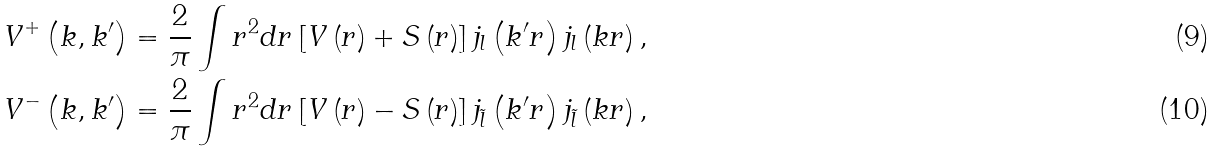Convert formula to latex. <formula><loc_0><loc_0><loc_500><loc_500>V ^ { + } \left ( k , k ^ { \prime } \right ) & = \frac { 2 } { \pi } \int r ^ { 2 } d r \left [ V \left ( r \right ) + S \left ( r \right ) \right ] j _ { l } \left ( k ^ { \prime } r \right ) j _ { l } \left ( k r \right ) , \\ V ^ { - } \left ( k , k ^ { \prime } \right ) & = \frac { 2 } { \pi } \int r ^ { 2 } d r \left [ V \left ( r \right ) - S \left ( r \right ) \right ] j _ { \tilde { l } } \left ( k ^ { \prime } r \right ) j _ { \tilde { l } } \left ( k r \right ) ,</formula> 